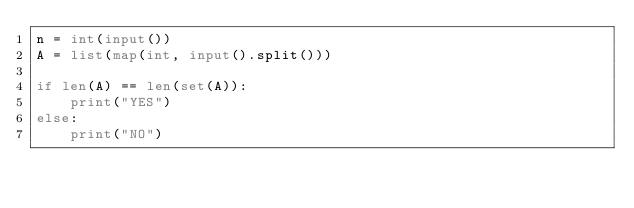Convert code to text. <code><loc_0><loc_0><loc_500><loc_500><_Python_>n = int(input())
A = list(map(int, input().split()))

if len(A) == len(set(A)):
    print("YES")
else:
    print("NO")
</code> 